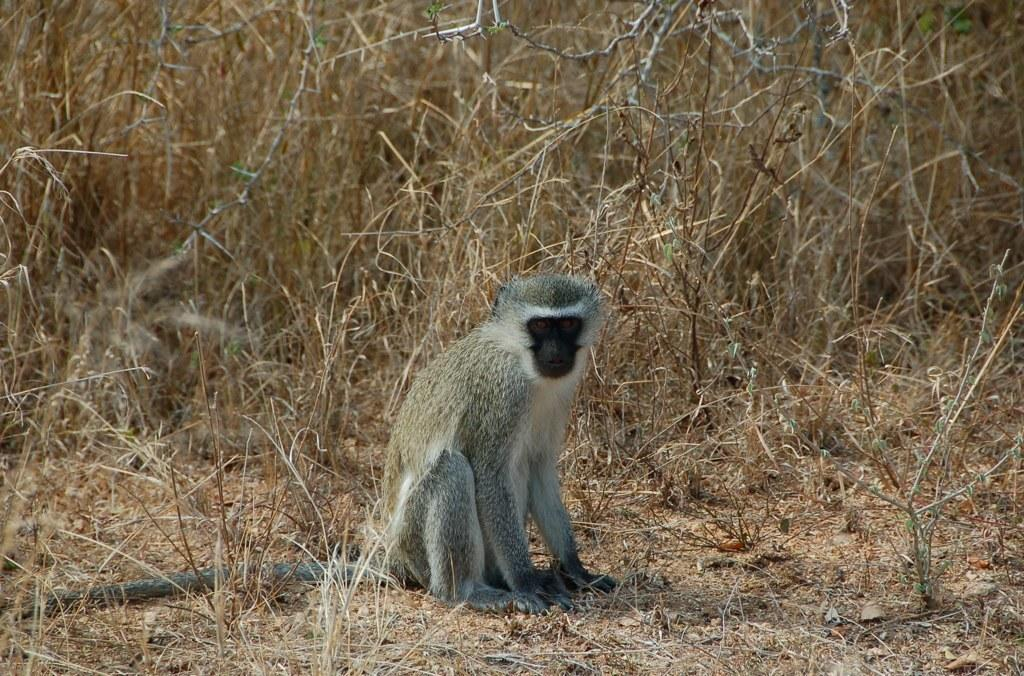What type of animal is present in the image? There is an animal in the image, but its specific type cannot be determined from the provided facts. Can you describe the position of the animal in the image? The animal is on the ground in the image. What type of natural environment is visible in the background of the image? There is grass visible in the background of the image. How does the animal wish the viewers good-bye in the image? The animal does not have the ability to communicate or express wishes, so it cannot wish the viewers good-bye in the image. 